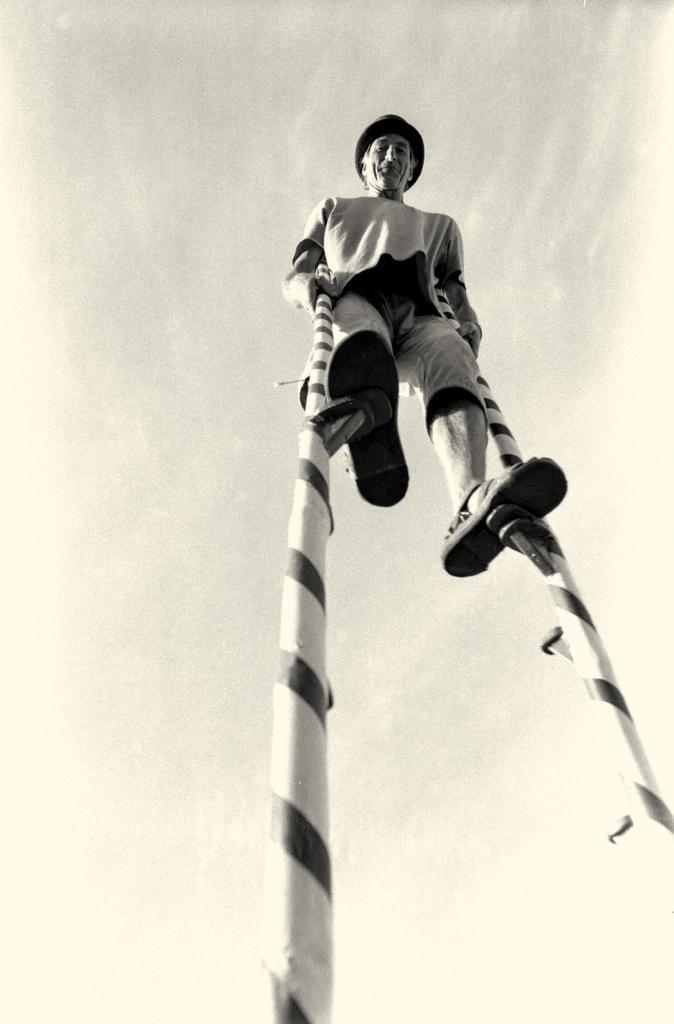Can you describe this image briefly? This is the picture of a black and white image and we can see a person standing on the poles. 